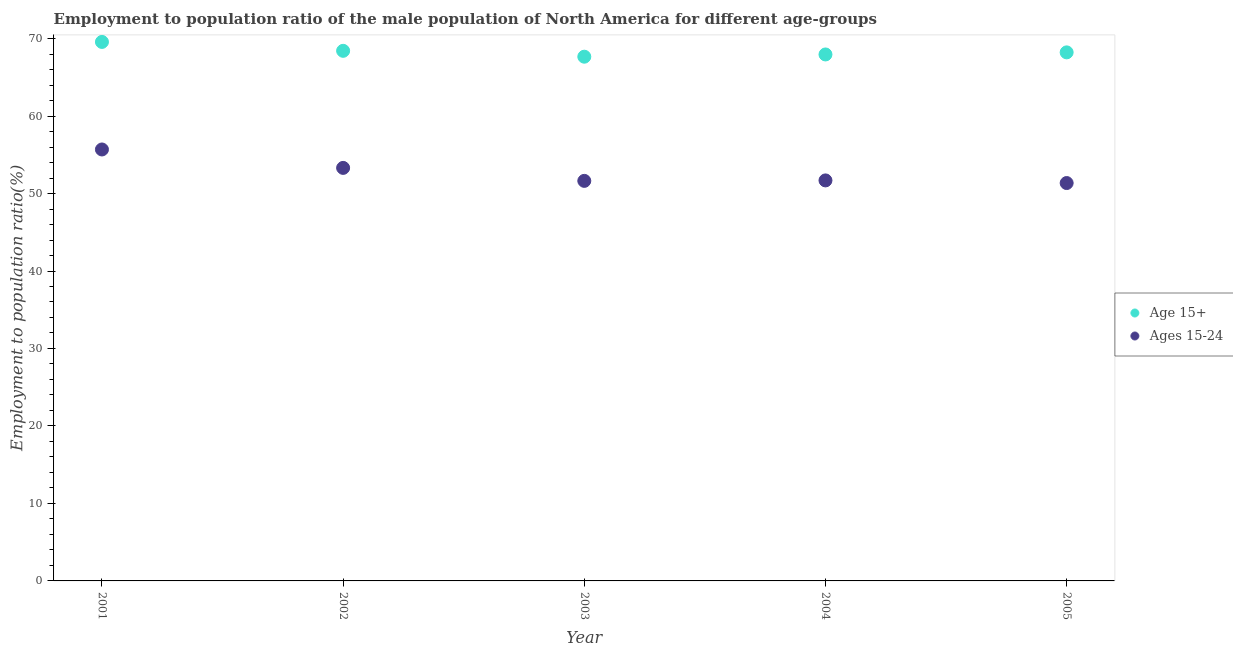Is the number of dotlines equal to the number of legend labels?
Your answer should be very brief. Yes. What is the employment to population ratio(age 15+) in 2004?
Ensure brevity in your answer.  67.95. Across all years, what is the maximum employment to population ratio(age 15+)?
Offer a very short reply. 69.57. Across all years, what is the minimum employment to population ratio(age 15-24)?
Provide a short and direct response. 51.35. In which year was the employment to population ratio(age 15+) minimum?
Provide a succinct answer. 2003. What is the total employment to population ratio(age 15+) in the graph?
Provide a succinct answer. 341.81. What is the difference between the employment to population ratio(age 15-24) in 2001 and that in 2003?
Provide a short and direct response. 4.05. What is the difference between the employment to population ratio(age 15-24) in 2001 and the employment to population ratio(age 15+) in 2004?
Ensure brevity in your answer.  -12.26. What is the average employment to population ratio(age 15+) per year?
Provide a succinct answer. 68.36. In the year 2001, what is the difference between the employment to population ratio(age 15+) and employment to population ratio(age 15-24)?
Ensure brevity in your answer.  13.88. In how many years, is the employment to population ratio(age 15-24) greater than 42 %?
Provide a succinct answer. 5. What is the ratio of the employment to population ratio(age 15-24) in 2002 to that in 2004?
Make the answer very short. 1.03. Is the employment to population ratio(age 15-24) in 2001 less than that in 2003?
Your answer should be compact. No. What is the difference between the highest and the second highest employment to population ratio(age 15+)?
Your answer should be compact. 1.15. What is the difference between the highest and the lowest employment to population ratio(age 15-24)?
Your answer should be very brief. 4.33. Is the sum of the employment to population ratio(age 15-24) in 2002 and 2004 greater than the maximum employment to population ratio(age 15+) across all years?
Offer a terse response. Yes. How many dotlines are there?
Your answer should be very brief. 2. How many years are there in the graph?
Your answer should be very brief. 5. What is the difference between two consecutive major ticks on the Y-axis?
Your answer should be very brief. 10. Does the graph contain any zero values?
Offer a terse response. No. How many legend labels are there?
Your response must be concise. 2. What is the title of the graph?
Your answer should be very brief. Employment to population ratio of the male population of North America for different age-groups. What is the label or title of the X-axis?
Your answer should be very brief. Year. What is the Employment to population ratio(%) of Age 15+ in 2001?
Keep it short and to the point. 69.57. What is the Employment to population ratio(%) in Ages 15-24 in 2001?
Provide a succinct answer. 55.69. What is the Employment to population ratio(%) of Age 15+ in 2002?
Your response must be concise. 68.42. What is the Employment to population ratio(%) in Ages 15-24 in 2002?
Offer a very short reply. 53.31. What is the Employment to population ratio(%) of Age 15+ in 2003?
Provide a short and direct response. 67.66. What is the Employment to population ratio(%) of Ages 15-24 in 2003?
Make the answer very short. 51.63. What is the Employment to population ratio(%) in Age 15+ in 2004?
Make the answer very short. 67.95. What is the Employment to population ratio(%) in Ages 15-24 in 2004?
Provide a short and direct response. 51.69. What is the Employment to population ratio(%) in Age 15+ in 2005?
Provide a succinct answer. 68.22. What is the Employment to population ratio(%) of Ages 15-24 in 2005?
Ensure brevity in your answer.  51.35. Across all years, what is the maximum Employment to population ratio(%) of Age 15+?
Provide a short and direct response. 69.57. Across all years, what is the maximum Employment to population ratio(%) of Ages 15-24?
Give a very brief answer. 55.69. Across all years, what is the minimum Employment to population ratio(%) in Age 15+?
Make the answer very short. 67.66. Across all years, what is the minimum Employment to population ratio(%) in Ages 15-24?
Your answer should be very brief. 51.35. What is the total Employment to population ratio(%) of Age 15+ in the graph?
Provide a succinct answer. 341.81. What is the total Employment to population ratio(%) of Ages 15-24 in the graph?
Keep it short and to the point. 263.67. What is the difference between the Employment to population ratio(%) in Age 15+ in 2001 and that in 2002?
Provide a short and direct response. 1.15. What is the difference between the Employment to population ratio(%) of Ages 15-24 in 2001 and that in 2002?
Ensure brevity in your answer.  2.38. What is the difference between the Employment to population ratio(%) in Age 15+ in 2001 and that in 2003?
Ensure brevity in your answer.  1.91. What is the difference between the Employment to population ratio(%) in Ages 15-24 in 2001 and that in 2003?
Offer a terse response. 4.05. What is the difference between the Employment to population ratio(%) of Age 15+ in 2001 and that in 2004?
Give a very brief answer. 1.62. What is the difference between the Employment to population ratio(%) in Ages 15-24 in 2001 and that in 2004?
Ensure brevity in your answer.  3.99. What is the difference between the Employment to population ratio(%) in Age 15+ in 2001 and that in 2005?
Your answer should be very brief. 1.35. What is the difference between the Employment to population ratio(%) of Ages 15-24 in 2001 and that in 2005?
Provide a succinct answer. 4.33. What is the difference between the Employment to population ratio(%) of Age 15+ in 2002 and that in 2003?
Keep it short and to the point. 0.76. What is the difference between the Employment to population ratio(%) in Ages 15-24 in 2002 and that in 2003?
Your answer should be compact. 1.67. What is the difference between the Employment to population ratio(%) of Age 15+ in 2002 and that in 2004?
Offer a very short reply. 0.47. What is the difference between the Employment to population ratio(%) in Ages 15-24 in 2002 and that in 2004?
Your response must be concise. 1.61. What is the difference between the Employment to population ratio(%) of Age 15+ in 2002 and that in 2005?
Keep it short and to the point. 0.2. What is the difference between the Employment to population ratio(%) of Ages 15-24 in 2002 and that in 2005?
Ensure brevity in your answer.  1.95. What is the difference between the Employment to population ratio(%) in Age 15+ in 2003 and that in 2004?
Make the answer very short. -0.29. What is the difference between the Employment to population ratio(%) in Ages 15-24 in 2003 and that in 2004?
Make the answer very short. -0.06. What is the difference between the Employment to population ratio(%) of Age 15+ in 2003 and that in 2005?
Your answer should be very brief. -0.56. What is the difference between the Employment to population ratio(%) of Ages 15-24 in 2003 and that in 2005?
Keep it short and to the point. 0.28. What is the difference between the Employment to population ratio(%) of Age 15+ in 2004 and that in 2005?
Provide a succinct answer. -0.27. What is the difference between the Employment to population ratio(%) in Ages 15-24 in 2004 and that in 2005?
Offer a very short reply. 0.34. What is the difference between the Employment to population ratio(%) of Age 15+ in 2001 and the Employment to population ratio(%) of Ages 15-24 in 2002?
Your response must be concise. 16.26. What is the difference between the Employment to population ratio(%) of Age 15+ in 2001 and the Employment to population ratio(%) of Ages 15-24 in 2003?
Offer a terse response. 17.93. What is the difference between the Employment to population ratio(%) of Age 15+ in 2001 and the Employment to population ratio(%) of Ages 15-24 in 2004?
Offer a very short reply. 17.87. What is the difference between the Employment to population ratio(%) in Age 15+ in 2001 and the Employment to population ratio(%) in Ages 15-24 in 2005?
Provide a short and direct response. 18.21. What is the difference between the Employment to population ratio(%) in Age 15+ in 2002 and the Employment to population ratio(%) in Ages 15-24 in 2003?
Your response must be concise. 16.78. What is the difference between the Employment to population ratio(%) of Age 15+ in 2002 and the Employment to population ratio(%) of Ages 15-24 in 2004?
Give a very brief answer. 16.72. What is the difference between the Employment to population ratio(%) of Age 15+ in 2002 and the Employment to population ratio(%) of Ages 15-24 in 2005?
Make the answer very short. 17.06. What is the difference between the Employment to population ratio(%) of Age 15+ in 2003 and the Employment to population ratio(%) of Ages 15-24 in 2004?
Your response must be concise. 15.97. What is the difference between the Employment to population ratio(%) of Age 15+ in 2003 and the Employment to population ratio(%) of Ages 15-24 in 2005?
Give a very brief answer. 16.31. What is the difference between the Employment to population ratio(%) in Age 15+ in 2004 and the Employment to population ratio(%) in Ages 15-24 in 2005?
Your response must be concise. 16.6. What is the average Employment to population ratio(%) of Age 15+ per year?
Give a very brief answer. 68.36. What is the average Employment to population ratio(%) in Ages 15-24 per year?
Provide a succinct answer. 52.73. In the year 2001, what is the difference between the Employment to population ratio(%) of Age 15+ and Employment to population ratio(%) of Ages 15-24?
Provide a succinct answer. 13.88. In the year 2002, what is the difference between the Employment to population ratio(%) in Age 15+ and Employment to population ratio(%) in Ages 15-24?
Offer a terse response. 15.11. In the year 2003, what is the difference between the Employment to population ratio(%) in Age 15+ and Employment to population ratio(%) in Ages 15-24?
Ensure brevity in your answer.  16.03. In the year 2004, what is the difference between the Employment to population ratio(%) in Age 15+ and Employment to population ratio(%) in Ages 15-24?
Keep it short and to the point. 16.26. In the year 2005, what is the difference between the Employment to population ratio(%) in Age 15+ and Employment to population ratio(%) in Ages 15-24?
Keep it short and to the point. 16.87. What is the ratio of the Employment to population ratio(%) in Age 15+ in 2001 to that in 2002?
Provide a succinct answer. 1.02. What is the ratio of the Employment to population ratio(%) of Ages 15-24 in 2001 to that in 2002?
Provide a short and direct response. 1.04. What is the ratio of the Employment to population ratio(%) of Age 15+ in 2001 to that in 2003?
Give a very brief answer. 1.03. What is the ratio of the Employment to population ratio(%) of Ages 15-24 in 2001 to that in 2003?
Ensure brevity in your answer.  1.08. What is the ratio of the Employment to population ratio(%) in Age 15+ in 2001 to that in 2004?
Provide a succinct answer. 1.02. What is the ratio of the Employment to population ratio(%) of Ages 15-24 in 2001 to that in 2004?
Keep it short and to the point. 1.08. What is the ratio of the Employment to population ratio(%) in Age 15+ in 2001 to that in 2005?
Make the answer very short. 1.02. What is the ratio of the Employment to population ratio(%) of Ages 15-24 in 2001 to that in 2005?
Your response must be concise. 1.08. What is the ratio of the Employment to population ratio(%) in Age 15+ in 2002 to that in 2003?
Give a very brief answer. 1.01. What is the ratio of the Employment to population ratio(%) of Ages 15-24 in 2002 to that in 2003?
Your response must be concise. 1.03. What is the ratio of the Employment to population ratio(%) of Age 15+ in 2002 to that in 2004?
Keep it short and to the point. 1.01. What is the ratio of the Employment to population ratio(%) in Ages 15-24 in 2002 to that in 2004?
Ensure brevity in your answer.  1.03. What is the ratio of the Employment to population ratio(%) in Age 15+ in 2002 to that in 2005?
Your answer should be compact. 1. What is the ratio of the Employment to population ratio(%) in Ages 15-24 in 2002 to that in 2005?
Your response must be concise. 1.04. What is the ratio of the Employment to population ratio(%) of Age 15+ in 2003 to that in 2005?
Give a very brief answer. 0.99. What is the ratio of the Employment to population ratio(%) of Ages 15-24 in 2003 to that in 2005?
Your response must be concise. 1.01. What is the ratio of the Employment to population ratio(%) in Age 15+ in 2004 to that in 2005?
Provide a succinct answer. 1. What is the ratio of the Employment to population ratio(%) of Ages 15-24 in 2004 to that in 2005?
Make the answer very short. 1.01. What is the difference between the highest and the second highest Employment to population ratio(%) in Age 15+?
Provide a short and direct response. 1.15. What is the difference between the highest and the second highest Employment to population ratio(%) in Ages 15-24?
Make the answer very short. 2.38. What is the difference between the highest and the lowest Employment to population ratio(%) of Age 15+?
Your response must be concise. 1.91. What is the difference between the highest and the lowest Employment to population ratio(%) of Ages 15-24?
Offer a terse response. 4.33. 